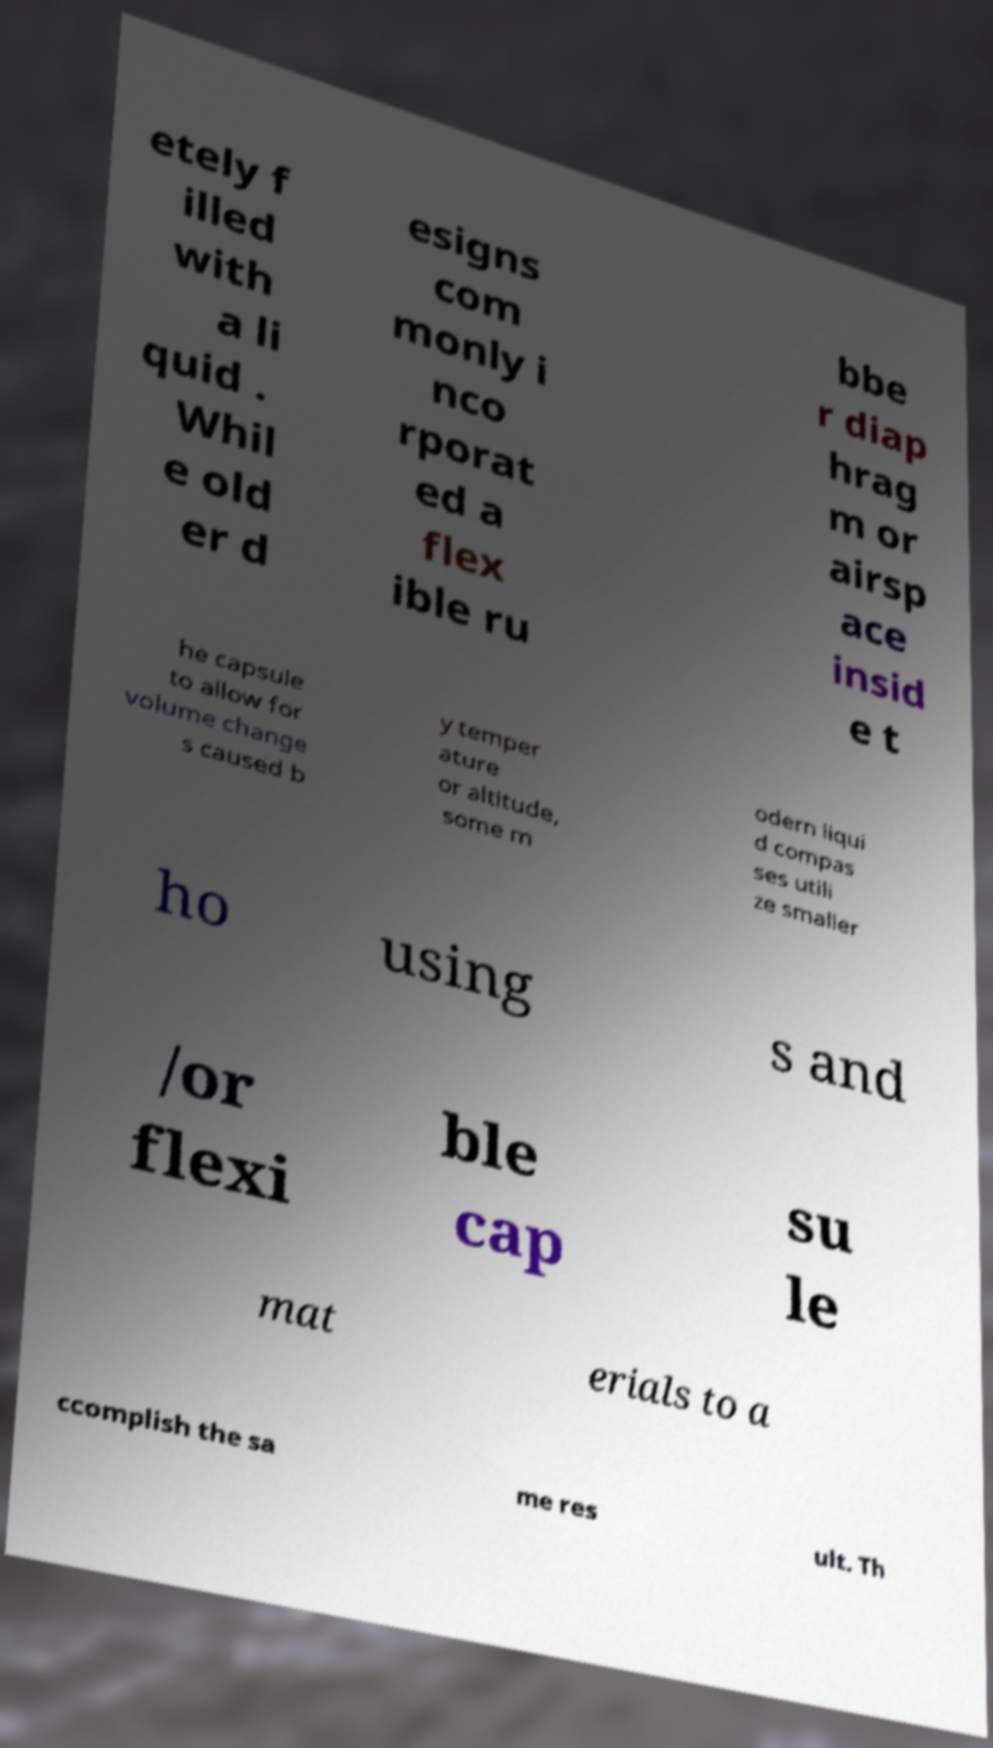What messages or text are displayed in this image? I need them in a readable, typed format. etely f illed with a li quid . Whil e old er d esigns com monly i nco rporat ed a flex ible ru bbe r diap hrag m or airsp ace insid e t he capsule to allow for volume change s caused b y temper ature or altitude, some m odern liqui d compas ses utili ze smaller ho using s and /or flexi ble cap su le mat erials to a ccomplish the sa me res ult. Th 